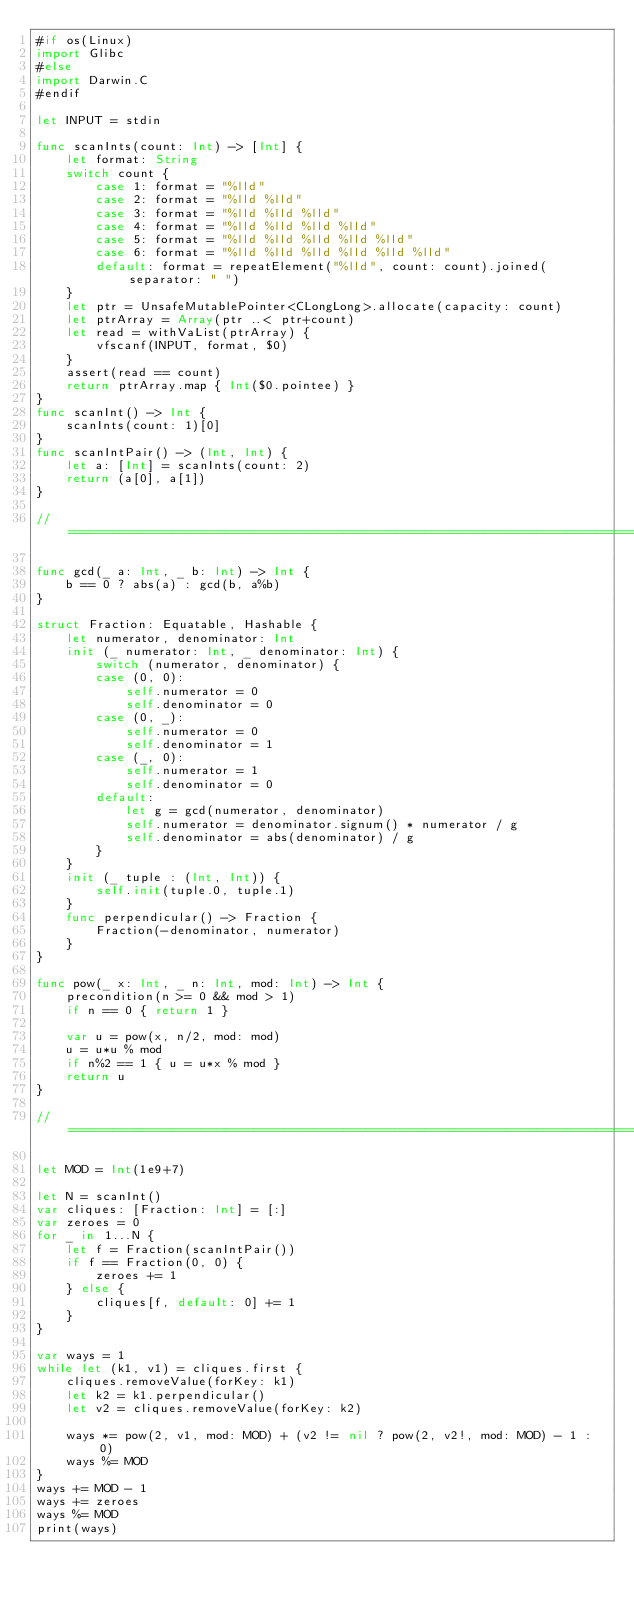Convert code to text. <code><loc_0><loc_0><loc_500><loc_500><_Swift_>#if os(Linux)
import Glibc
#else
import Darwin.C
#endif

let INPUT = stdin

func scanInts(count: Int) -> [Int] {
    let format: String
    switch count {
        case 1: format = "%lld"
        case 2: format = "%lld %lld"
        case 3: format = "%lld %lld %lld"
        case 4: format = "%lld %lld %lld %lld"
        case 5: format = "%lld %lld %lld %lld %lld"
        case 6: format = "%lld %lld %lld %lld %lld %lld"
        default: format = repeatElement("%lld", count: count).joined(separator: " ")
    }
    let ptr = UnsafeMutablePointer<CLongLong>.allocate(capacity: count)
    let ptrArray = Array(ptr ..< ptr+count)
    let read = withVaList(ptrArray) {
        vfscanf(INPUT, format, $0)
    }
    assert(read == count)
    return ptrArray.map { Int($0.pointee) }
}
func scanInt() -> Int {
    scanInts(count: 1)[0]
}
func scanIntPair() -> (Int, Int) {
    let a: [Int] = scanInts(count: 2)
    return (a[0], a[1])
}

//=============================================================================

func gcd(_ a: Int, _ b: Int) -> Int {
    b == 0 ? abs(a) : gcd(b, a%b)
}

struct Fraction: Equatable, Hashable {
    let numerator, denominator: Int
    init (_ numerator: Int, _ denominator: Int) {
        switch (numerator, denominator) {
        case (0, 0):
            self.numerator = 0
            self.denominator = 0
        case (0, _):
            self.numerator = 0
            self.denominator = 1
        case (_, 0):
            self.numerator = 1
            self.denominator = 0
        default:
            let g = gcd(numerator, denominator)
            self.numerator = denominator.signum() * numerator / g
            self.denominator = abs(denominator) / g
        }
    }
    init (_ tuple : (Int, Int)) {
        self.init(tuple.0, tuple.1)
    }
    func perpendicular() -> Fraction {
        Fraction(-denominator, numerator)
    }
}

func pow(_ x: Int, _ n: Int, mod: Int) -> Int {
    precondition(n >= 0 && mod > 1)
    if n == 0 { return 1 }

    var u = pow(x, n/2, mod: mod)
    u = u*u % mod
    if n%2 == 1 { u = u*x % mod }
    return u
}

//=============================================================================

let MOD = Int(1e9+7)

let N = scanInt()
var cliques: [Fraction: Int] = [:]
var zeroes = 0
for _ in 1...N {
    let f = Fraction(scanIntPair())
    if f == Fraction(0, 0) {
        zeroes += 1
    } else {
        cliques[f, default: 0] += 1
    }
}

var ways = 1
while let (k1, v1) = cliques.first {
    cliques.removeValue(forKey: k1)
    let k2 = k1.perpendicular()
    let v2 = cliques.removeValue(forKey: k2)

    ways *= pow(2, v1, mod: MOD) + (v2 != nil ? pow(2, v2!, mod: MOD) - 1 : 0)
    ways %= MOD
}
ways += MOD - 1
ways += zeroes
ways %= MOD
print(ways)
</code> 